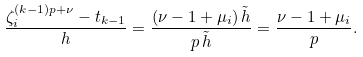<formula> <loc_0><loc_0><loc_500><loc_500>\frac { \zeta _ { i } ^ { ( k - 1 ) p + \nu } - t _ { k - 1 } } { h } = \frac { ( \nu - 1 + \mu _ { i } ) \, \tilde { h } } { p \, \tilde { h } } = \frac { \nu - 1 + \mu _ { i } } { p } .</formula> 